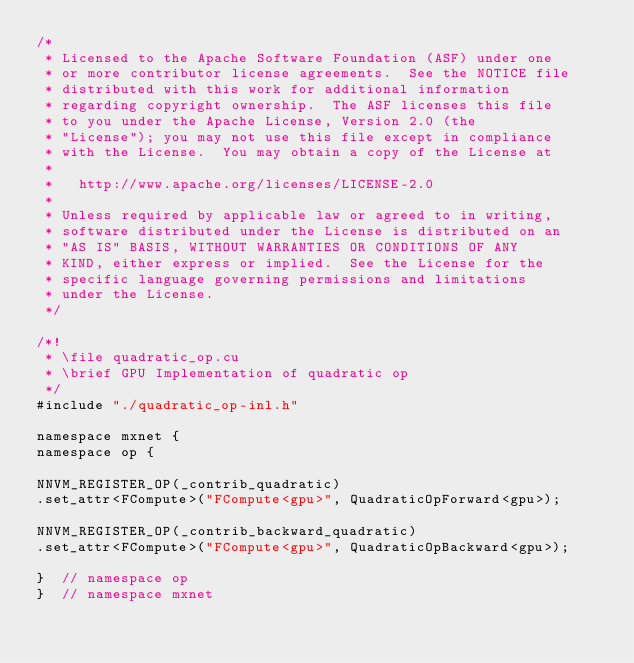Convert code to text. <code><loc_0><loc_0><loc_500><loc_500><_Cuda_>/*
 * Licensed to the Apache Software Foundation (ASF) under one
 * or more contributor license agreements.  See the NOTICE file
 * distributed with this work for additional information
 * regarding copyright ownership.  The ASF licenses this file
 * to you under the Apache License, Version 2.0 (the
 * "License"); you may not use this file except in compliance
 * with the License.  You may obtain a copy of the License at
 *
 *   http://www.apache.org/licenses/LICENSE-2.0
 *
 * Unless required by applicable law or agreed to in writing,
 * software distributed under the License is distributed on an
 * "AS IS" BASIS, WITHOUT WARRANTIES OR CONDITIONS OF ANY
 * KIND, either express or implied.  See the License for the
 * specific language governing permissions and limitations
 * under the License.
 */

/*!
 * \file quadratic_op.cu
 * \brief GPU Implementation of quadratic op
 */
#include "./quadratic_op-inl.h"

namespace mxnet {
namespace op {

NNVM_REGISTER_OP(_contrib_quadratic)
.set_attr<FCompute>("FCompute<gpu>", QuadraticOpForward<gpu>);

NNVM_REGISTER_OP(_contrib_backward_quadratic)
.set_attr<FCompute>("FCompute<gpu>", QuadraticOpBackward<gpu>);

}  // namespace op
}  // namespace mxnet
</code> 